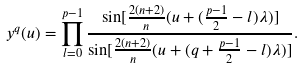<formula> <loc_0><loc_0><loc_500><loc_500>y ^ { q } ( u ) = \prod ^ { p - 1 } _ { l = 0 } \frac { \sin [ \frac { 2 ( n + 2 ) } { n } ( u + ( \frac { p - 1 } { 2 } - l ) \lambda ) ] } { \sin [ \frac { 2 ( n + 2 ) } { n } ( u + ( q + \frac { p - 1 } { 2 } - l ) \lambda ) ] } .</formula> 